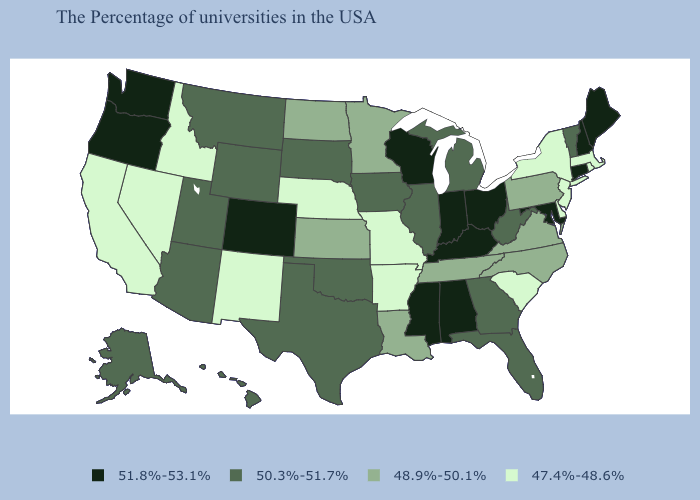Among the states that border Utah , which have the lowest value?
Answer briefly. New Mexico, Idaho, Nevada. Name the states that have a value in the range 48.9%-50.1%?
Give a very brief answer. Pennsylvania, Virginia, North Carolina, Tennessee, Louisiana, Minnesota, Kansas, North Dakota. Does Connecticut have the highest value in the USA?
Concise answer only. Yes. Name the states that have a value in the range 48.9%-50.1%?
Give a very brief answer. Pennsylvania, Virginia, North Carolina, Tennessee, Louisiana, Minnesota, Kansas, North Dakota. How many symbols are there in the legend?
Short answer required. 4. What is the value of New Mexico?
Keep it brief. 47.4%-48.6%. Is the legend a continuous bar?
Short answer required. No. Does Washington have the highest value in the West?
Give a very brief answer. Yes. Which states have the highest value in the USA?
Be succinct. Maine, New Hampshire, Connecticut, Maryland, Ohio, Kentucky, Indiana, Alabama, Wisconsin, Mississippi, Colorado, Washington, Oregon. What is the value of Vermont?
Be succinct. 50.3%-51.7%. How many symbols are there in the legend?
Short answer required. 4. What is the lowest value in states that border New Mexico?
Be succinct. 50.3%-51.7%. What is the value of Texas?
Give a very brief answer. 50.3%-51.7%. Among the states that border Nebraska , which have the lowest value?
Quick response, please. Missouri. Does Texas have a higher value than Connecticut?
Give a very brief answer. No. 